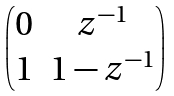<formula> <loc_0><loc_0><loc_500><loc_500>\begin{pmatrix} 0 & z ^ { - 1 } \\ 1 & 1 - z ^ { - 1 } \end{pmatrix}</formula> 